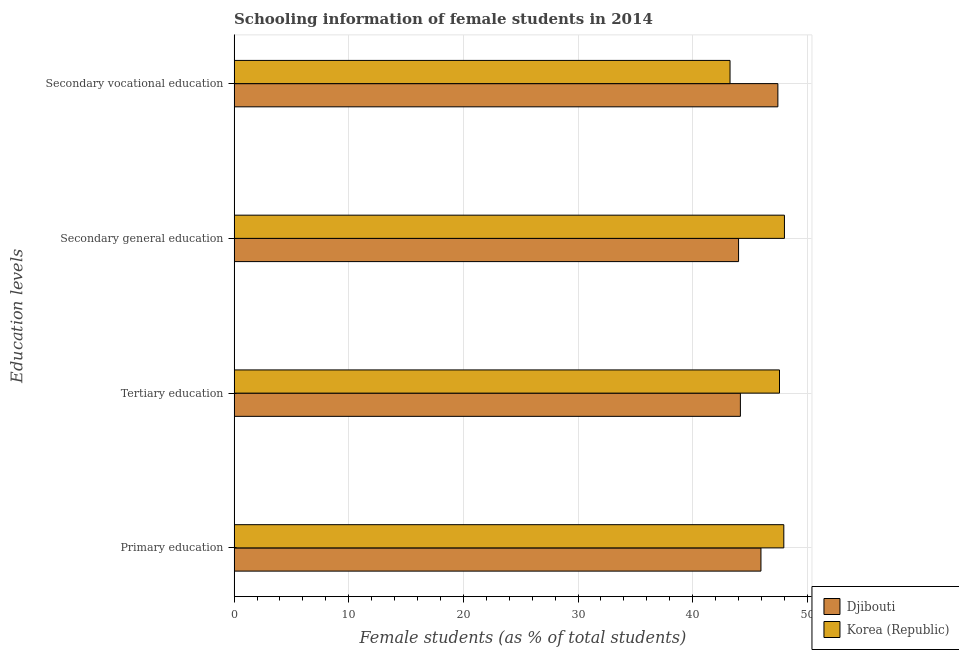Are the number of bars on each tick of the Y-axis equal?
Your answer should be very brief. Yes. How many bars are there on the 2nd tick from the bottom?
Your response must be concise. 2. What is the label of the 3rd group of bars from the top?
Provide a short and direct response. Tertiary education. What is the percentage of female students in secondary education in Korea (Republic)?
Keep it short and to the point. 48.01. Across all countries, what is the maximum percentage of female students in primary education?
Give a very brief answer. 47.95. Across all countries, what is the minimum percentage of female students in secondary vocational education?
Provide a succinct answer. 43.26. In which country was the percentage of female students in secondary vocational education maximum?
Provide a succinct answer. Djibouti. In which country was the percentage of female students in secondary education minimum?
Offer a very short reply. Djibouti. What is the total percentage of female students in secondary vocational education in the graph?
Your response must be concise. 90.69. What is the difference between the percentage of female students in tertiary education in Djibouti and that in Korea (Republic)?
Ensure brevity in your answer.  -3.41. What is the difference between the percentage of female students in secondary vocational education in Djibouti and the percentage of female students in secondary education in Korea (Republic)?
Offer a very short reply. -0.57. What is the average percentage of female students in primary education per country?
Give a very brief answer. 46.95. What is the difference between the percentage of female students in primary education and percentage of female students in secondary education in Djibouti?
Provide a succinct answer. 1.95. In how many countries, is the percentage of female students in tertiary education greater than 22 %?
Provide a short and direct response. 2. What is the ratio of the percentage of female students in tertiary education in Djibouti to that in Korea (Republic)?
Provide a short and direct response. 0.93. What is the difference between the highest and the second highest percentage of female students in tertiary education?
Your answer should be very brief. 3.41. What is the difference between the highest and the lowest percentage of female students in primary education?
Make the answer very short. 2. In how many countries, is the percentage of female students in secondary vocational education greater than the average percentage of female students in secondary vocational education taken over all countries?
Offer a very short reply. 1. Is it the case that in every country, the sum of the percentage of female students in secondary education and percentage of female students in primary education is greater than the sum of percentage of female students in tertiary education and percentage of female students in secondary vocational education?
Offer a very short reply. No. What does the 2nd bar from the top in Secondary vocational education represents?
Your answer should be very brief. Djibouti. What does the 1st bar from the bottom in Secondary vocational education represents?
Your answer should be very brief. Djibouti. Is it the case that in every country, the sum of the percentage of female students in primary education and percentage of female students in tertiary education is greater than the percentage of female students in secondary education?
Your answer should be compact. Yes. How many countries are there in the graph?
Ensure brevity in your answer.  2. Does the graph contain any zero values?
Your answer should be compact. No. Where does the legend appear in the graph?
Your answer should be compact. Bottom right. How are the legend labels stacked?
Your response must be concise. Vertical. What is the title of the graph?
Your answer should be very brief. Schooling information of female students in 2014. What is the label or title of the X-axis?
Ensure brevity in your answer.  Female students (as % of total students). What is the label or title of the Y-axis?
Give a very brief answer. Education levels. What is the Female students (as % of total students) of Djibouti in Primary education?
Provide a succinct answer. 45.96. What is the Female students (as % of total students) in Korea (Republic) in Primary education?
Provide a succinct answer. 47.95. What is the Female students (as % of total students) in Djibouti in Tertiary education?
Offer a very short reply. 44.16. What is the Female students (as % of total students) of Korea (Republic) in Tertiary education?
Your answer should be compact. 47.58. What is the Female students (as % of total students) of Djibouti in Secondary general education?
Your answer should be compact. 44. What is the Female students (as % of total students) of Korea (Republic) in Secondary general education?
Give a very brief answer. 48.01. What is the Female students (as % of total students) of Djibouti in Secondary vocational education?
Your answer should be compact. 47.43. What is the Female students (as % of total students) of Korea (Republic) in Secondary vocational education?
Keep it short and to the point. 43.26. Across all Education levels, what is the maximum Female students (as % of total students) in Djibouti?
Make the answer very short. 47.43. Across all Education levels, what is the maximum Female students (as % of total students) of Korea (Republic)?
Ensure brevity in your answer.  48.01. Across all Education levels, what is the minimum Female students (as % of total students) of Djibouti?
Make the answer very short. 44. Across all Education levels, what is the minimum Female students (as % of total students) in Korea (Republic)?
Keep it short and to the point. 43.26. What is the total Female students (as % of total students) of Djibouti in the graph?
Your answer should be compact. 181.56. What is the total Female students (as % of total students) in Korea (Republic) in the graph?
Give a very brief answer. 186.79. What is the difference between the Female students (as % of total students) of Djibouti in Primary education and that in Tertiary education?
Your response must be concise. 1.79. What is the difference between the Female students (as % of total students) in Korea (Republic) in Primary education and that in Tertiary education?
Give a very brief answer. 0.38. What is the difference between the Female students (as % of total students) in Djibouti in Primary education and that in Secondary general education?
Your answer should be very brief. 1.95. What is the difference between the Female students (as % of total students) in Korea (Republic) in Primary education and that in Secondary general education?
Give a very brief answer. -0.05. What is the difference between the Female students (as % of total students) of Djibouti in Primary education and that in Secondary vocational education?
Offer a very short reply. -1.48. What is the difference between the Female students (as % of total students) of Korea (Republic) in Primary education and that in Secondary vocational education?
Provide a succinct answer. 4.69. What is the difference between the Female students (as % of total students) of Djibouti in Tertiary education and that in Secondary general education?
Give a very brief answer. 0.16. What is the difference between the Female students (as % of total students) of Korea (Republic) in Tertiary education and that in Secondary general education?
Provide a succinct answer. -0.43. What is the difference between the Female students (as % of total students) of Djibouti in Tertiary education and that in Secondary vocational education?
Provide a short and direct response. -3.27. What is the difference between the Female students (as % of total students) of Korea (Republic) in Tertiary education and that in Secondary vocational education?
Provide a succinct answer. 4.31. What is the difference between the Female students (as % of total students) of Djibouti in Secondary general education and that in Secondary vocational education?
Offer a very short reply. -3.43. What is the difference between the Female students (as % of total students) of Korea (Republic) in Secondary general education and that in Secondary vocational education?
Offer a very short reply. 4.74. What is the difference between the Female students (as % of total students) in Djibouti in Primary education and the Female students (as % of total students) in Korea (Republic) in Tertiary education?
Your response must be concise. -1.62. What is the difference between the Female students (as % of total students) in Djibouti in Primary education and the Female students (as % of total students) in Korea (Republic) in Secondary general education?
Offer a very short reply. -2.05. What is the difference between the Female students (as % of total students) in Djibouti in Primary education and the Female students (as % of total students) in Korea (Republic) in Secondary vocational education?
Keep it short and to the point. 2.7. What is the difference between the Female students (as % of total students) in Djibouti in Tertiary education and the Female students (as % of total students) in Korea (Republic) in Secondary general education?
Your answer should be very brief. -3.84. What is the difference between the Female students (as % of total students) in Djibouti in Tertiary education and the Female students (as % of total students) in Korea (Republic) in Secondary vocational education?
Offer a very short reply. 0.9. What is the difference between the Female students (as % of total students) in Djibouti in Secondary general education and the Female students (as % of total students) in Korea (Republic) in Secondary vocational education?
Your answer should be compact. 0.74. What is the average Female students (as % of total students) of Djibouti per Education levels?
Keep it short and to the point. 45.39. What is the average Female students (as % of total students) in Korea (Republic) per Education levels?
Make the answer very short. 46.7. What is the difference between the Female students (as % of total students) of Djibouti and Female students (as % of total students) of Korea (Republic) in Primary education?
Offer a terse response. -2. What is the difference between the Female students (as % of total students) of Djibouti and Female students (as % of total students) of Korea (Republic) in Tertiary education?
Make the answer very short. -3.41. What is the difference between the Female students (as % of total students) in Djibouti and Female students (as % of total students) in Korea (Republic) in Secondary general education?
Offer a very short reply. -4. What is the difference between the Female students (as % of total students) in Djibouti and Female students (as % of total students) in Korea (Republic) in Secondary vocational education?
Offer a terse response. 4.17. What is the ratio of the Female students (as % of total students) in Djibouti in Primary education to that in Tertiary education?
Keep it short and to the point. 1.04. What is the ratio of the Female students (as % of total students) of Korea (Republic) in Primary education to that in Tertiary education?
Provide a succinct answer. 1.01. What is the ratio of the Female students (as % of total students) of Djibouti in Primary education to that in Secondary general education?
Your response must be concise. 1.04. What is the ratio of the Female students (as % of total students) in Korea (Republic) in Primary education to that in Secondary general education?
Keep it short and to the point. 1. What is the ratio of the Female students (as % of total students) of Djibouti in Primary education to that in Secondary vocational education?
Offer a very short reply. 0.97. What is the ratio of the Female students (as % of total students) in Korea (Republic) in Primary education to that in Secondary vocational education?
Your answer should be compact. 1.11. What is the ratio of the Female students (as % of total students) of Djibouti in Tertiary education to that in Secondary general education?
Make the answer very short. 1. What is the ratio of the Female students (as % of total students) in Korea (Republic) in Tertiary education to that in Secondary general education?
Provide a short and direct response. 0.99. What is the ratio of the Female students (as % of total students) of Korea (Republic) in Tertiary education to that in Secondary vocational education?
Give a very brief answer. 1.1. What is the ratio of the Female students (as % of total students) in Djibouti in Secondary general education to that in Secondary vocational education?
Your answer should be very brief. 0.93. What is the ratio of the Female students (as % of total students) of Korea (Republic) in Secondary general education to that in Secondary vocational education?
Your answer should be compact. 1.11. What is the difference between the highest and the second highest Female students (as % of total students) of Djibouti?
Offer a very short reply. 1.48. What is the difference between the highest and the second highest Female students (as % of total students) in Korea (Republic)?
Provide a short and direct response. 0.05. What is the difference between the highest and the lowest Female students (as % of total students) of Djibouti?
Your answer should be compact. 3.43. What is the difference between the highest and the lowest Female students (as % of total students) in Korea (Republic)?
Offer a very short reply. 4.74. 